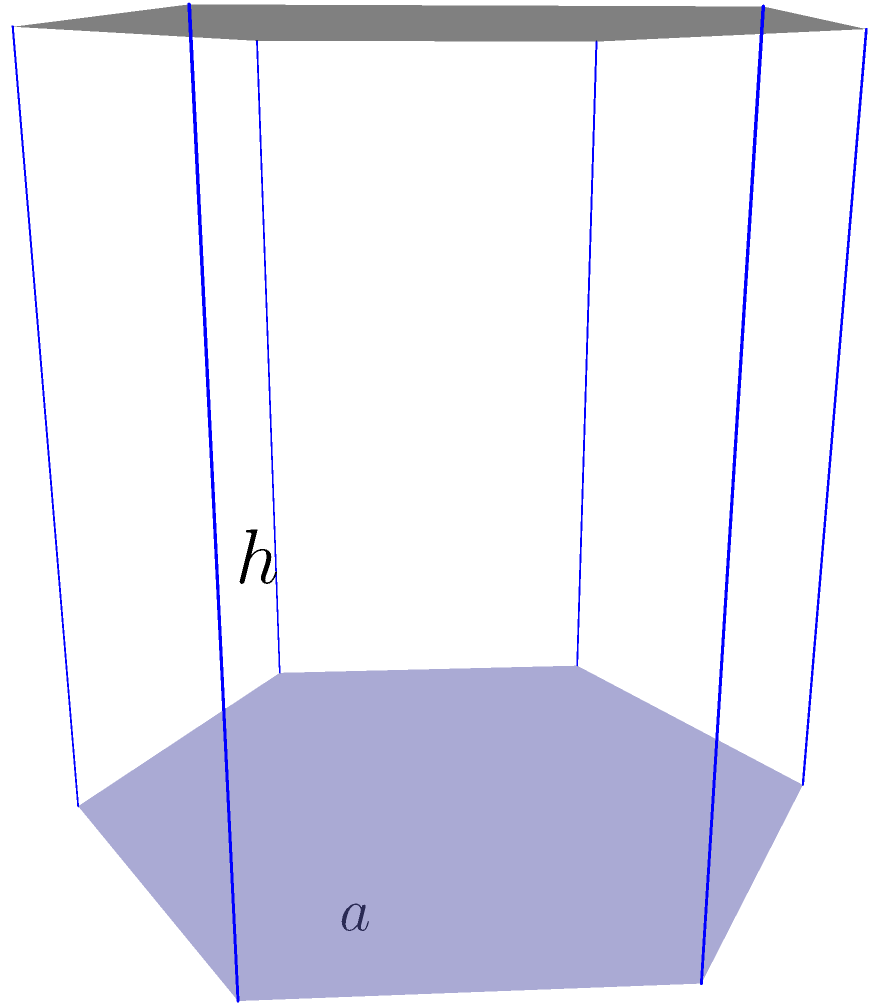A hexagonal prism-shaped therapy tool storage unit has a side length of 2 feet and a height of 4 feet. Calculate the lateral surface area of this storage unit. To calculate the lateral surface area of a hexagonal prism, we need to follow these steps:

1) The lateral surface area of a prism is the area of all the rectangular faces (excluding the top and bottom).

2) For a hexagonal prism, there are 6 rectangular faces.

3) Each rectangular face has a width equal to the side length of the hexagon (a) and a height equal to the height of the prism (h).

4) The area of one rectangular face is therefore: $A_{face} = a \times h = 2 \times 4 = 8$ sq ft

5) Since there are 6 identical faces, we multiply this area by 6:

   Lateral Surface Area = $6 \times A_{face} = 6 \times 8 = 48$ sq ft

Therefore, the lateral surface area of the hexagonal prism-shaped storage unit is 48 square feet.
Answer: 48 sq ft 